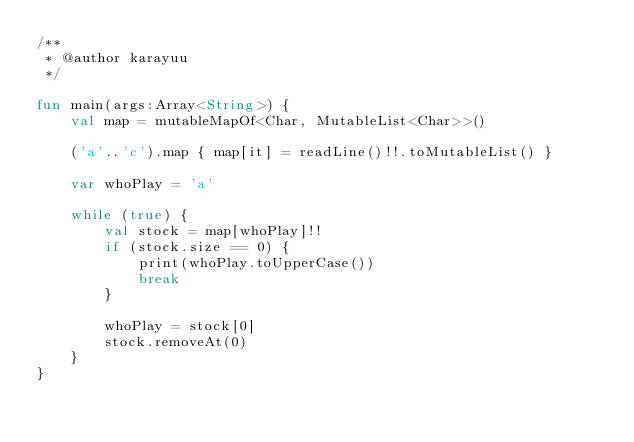<code> <loc_0><loc_0><loc_500><loc_500><_Kotlin_>/**
 * @author karayuu
 */

fun main(args:Array<String>) {
    val map = mutableMapOf<Char, MutableList<Char>>()

    ('a'..'c').map { map[it] = readLine()!!.toMutableList() }

    var whoPlay = 'a'

    while (true) {
        val stock = map[whoPlay]!!
        if (stock.size == 0) {
            print(whoPlay.toUpperCase())
            break
        }

        whoPlay = stock[0]
        stock.removeAt(0)
    }
}</code> 